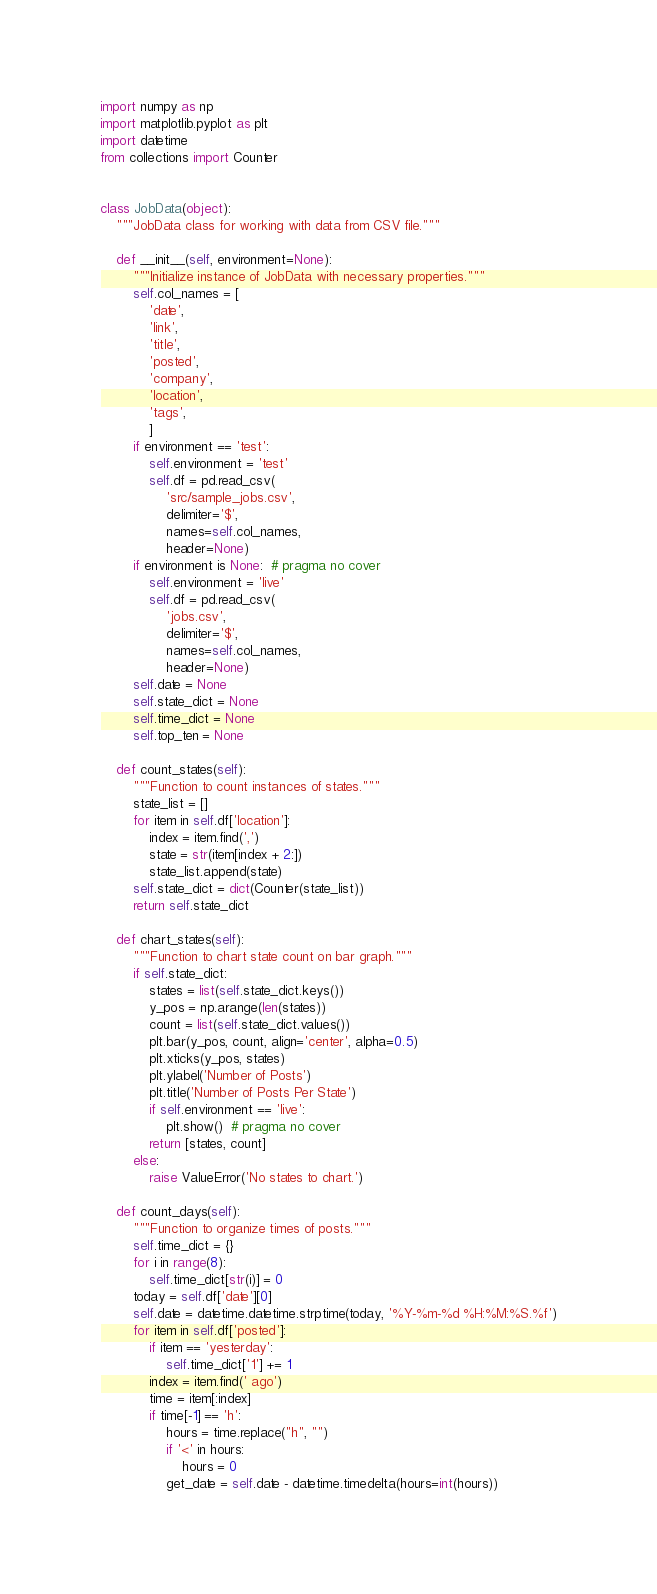Convert code to text. <code><loc_0><loc_0><loc_500><loc_500><_Python_>import numpy as np
import matplotlib.pyplot as plt
import datetime
from collections import Counter


class JobData(object):
    """JobData class for working with data from CSV file."""

    def __init__(self, environment=None):
        """Initialize instance of JobData with necessary properties."""
        self.col_names = [
            'date',
            'link',
            'title',
            'posted',
            'company',
            'location',
            'tags',
            ]
        if environment == 'test':
            self.environment = 'test'
            self.df = pd.read_csv(
                'src/sample_jobs.csv',
                delimiter='$',
                names=self.col_names,
                header=None)
        if environment is None:  # pragma no cover
            self.environment = 'live'
            self.df = pd.read_csv(
                'jobs.csv',
                delimiter='$',
                names=self.col_names,
                header=None)
        self.date = None
        self.state_dict = None
        self.time_dict = None
        self.top_ten = None

    def count_states(self):
        """Function to count instances of states."""
        state_list = []
        for item in self.df['location']:
            index = item.find(',')
            state = str(item[index + 2:])
            state_list.append(state)
        self.state_dict = dict(Counter(state_list))
        return self.state_dict

    def chart_states(self):
        """Function to chart state count on bar graph."""
        if self.state_dict:
            states = list(self.state_dict.keys())
            y_pos = np.arange(len(states))
            count = list(self.state_dict.values())
            plt.bar(y_pos, count, align='center', alpha=0.5)
            plt.xticks(y_pos, states)
            plt.ylabel('Number of Posts')
            plt.title('Number of Posts Per State')
            if self.environment == 'live':
                plt.show()  # pragma no cover
            return [states, count]
        else:
            raise ValueError('No states to chart.')

    def count_days(self):
        """Function to organize times of posts."""
        self.time_dict = {}
        for i in range(8):
            self.time_dict[str(i)] = 0
        today = self.df['date'][0]
        self.date = datetime.datetime.strptime(today, '%Y-%m-%d %H:%M:%S.%f')
        for item in self.df['posted']:
            if item == 'yesterday':
                self.time_dict['1'] += 1
            index = item.find(' ago')
            time = item[:index]
            if time[-1] == 'h':
                hours = time.replace("h", "")
                if '<' in hours:
                    hours = 0
                get_date = self.date - datetime.timedelta(hours=int(hours))</code> 